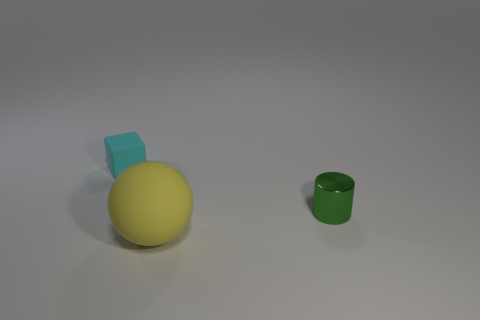Add 2 large balls. How many objects exist? 5 Subtract all blocks. How many objects are left? 2 Add 2 small green cylinders. How many small green cylinders exist? 3 Subtract 0 purple cylinders. How many objects are left? 3 Subtract all yellow things. Subtract all small shiny cylinders. How many objects are left? 1 Add 2 large balls. How many large balls are left? 3 